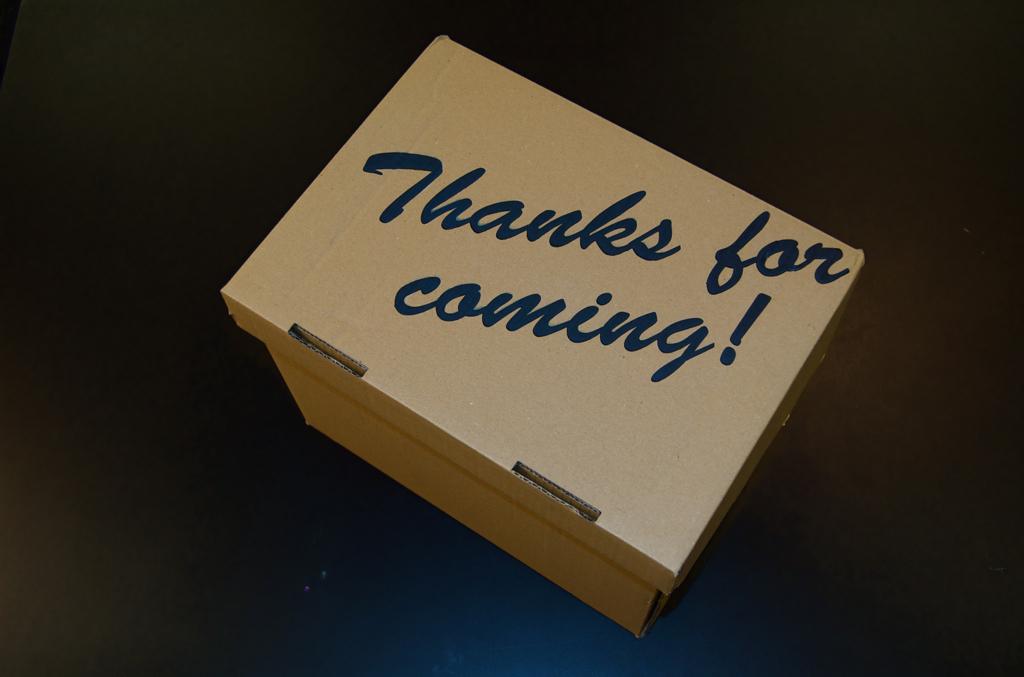What does the cardboard box say?
Provide a succinct answer. Thanks for coming. 